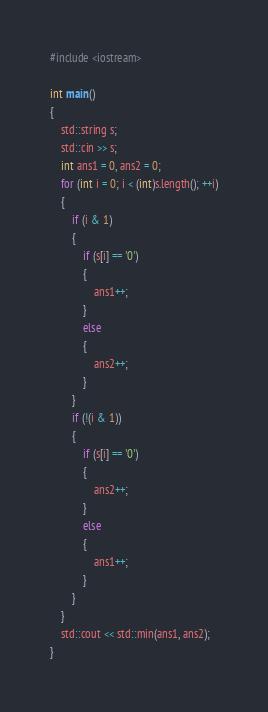Convert code to text. <code><loc_0><loc_0><loc_500><loc_500><_C++_>#include <iostream>

int main()
{
	std::string s;
	std::cin >> s;
	int ans1 = 0, ans2 = 0;
	for (int i = 0; i < (int)s.length(); ++i)
	{
		if (i & 1)
		{
			if (s[i] == '0')
			{
				ans1++;
			}
			else
			{
				ans2++;
			}
		}
		if (!(i & 1))
		{
			if (s[i] == '0')
			{
				ans2++;
			}
			else
			{
				ans1++;
			}
		}
	}
	std::cout << std::min(ans1, ans2);
}</code> 